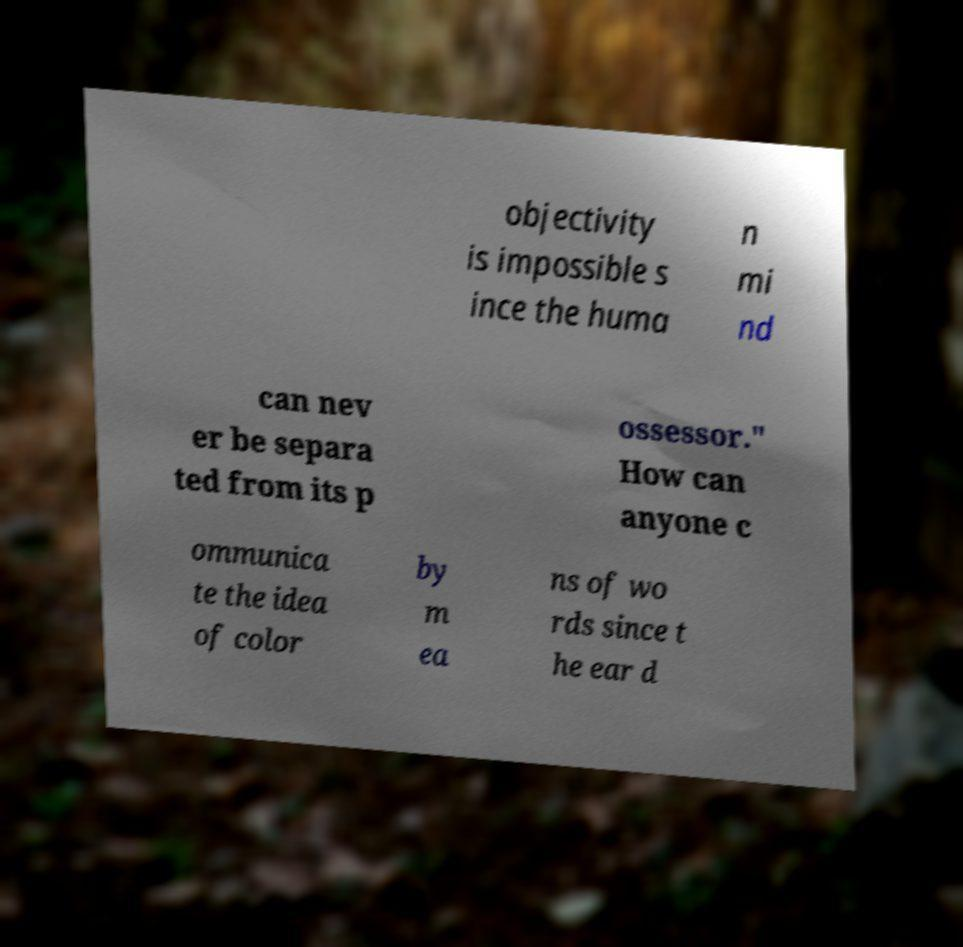I need the written content from this picture converted into text. Can you do that? objectivity is impossible s ince the huma n mi nd can nev er be separa ted from its p ossessor." How can anyone c ommunica te the idea of color by m ea ns of wo rds since t he ear d 